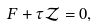Convert formula to latex. <formula><loc_0><loc_0><loc_500><loc_500>F + \tau \mathcal { Z } = 0 ,</formula> 